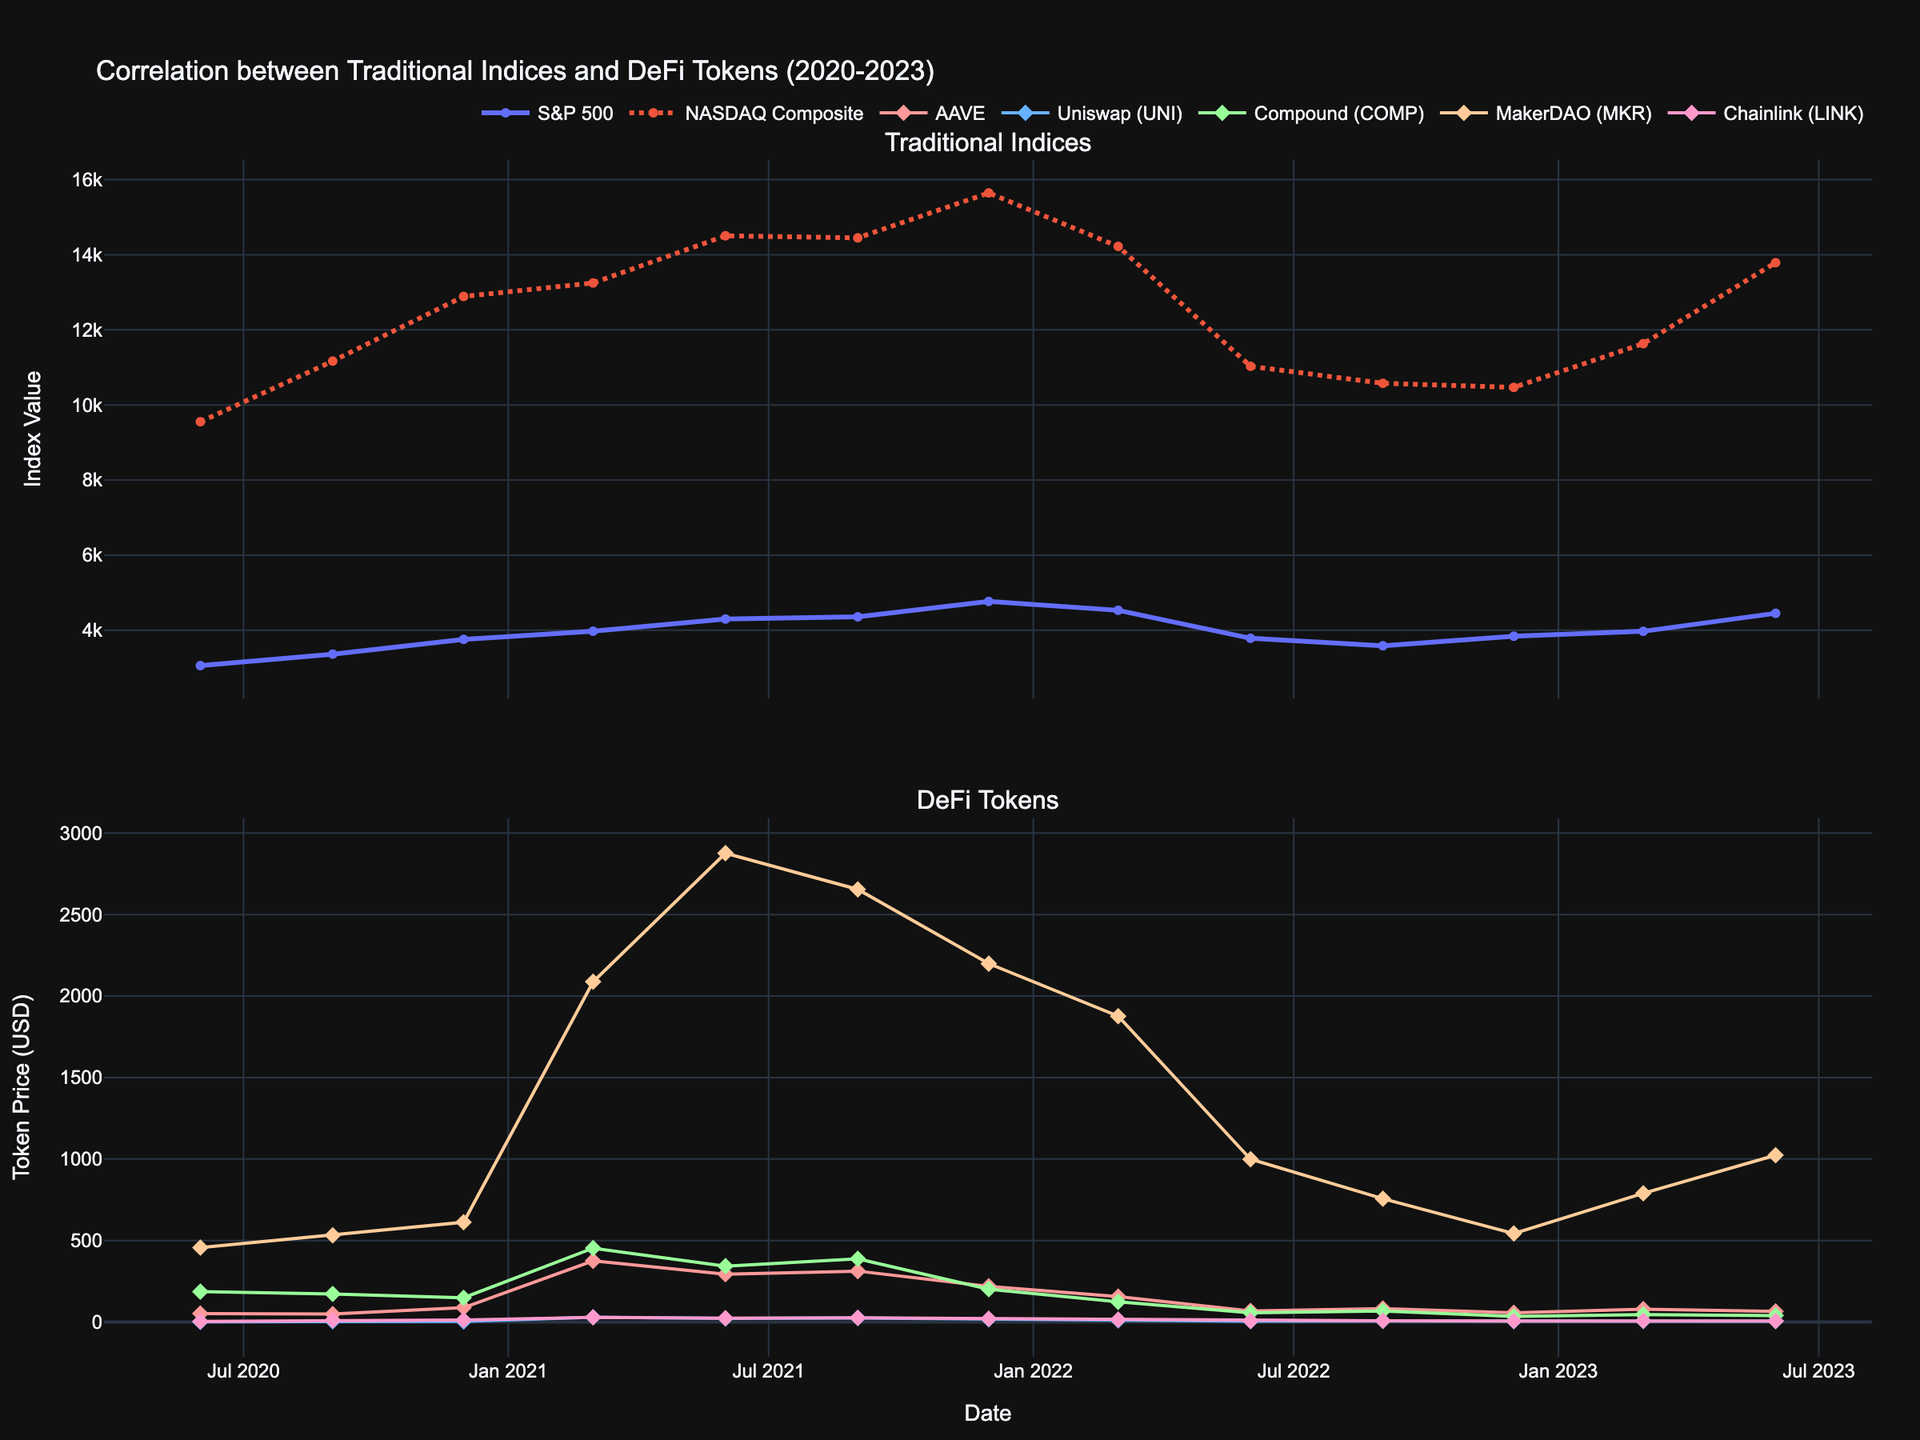Which DeFi token had the highest price in March 2021? Looking at the second subplot, March 2021 shows MakerDAO (MKR) reaching the highest price among the DeFi tokens.
Answer: MakerDAO (MKR) How did the trend of the S&P 500 index compare to the NASDAQ Composite from June 2020 to June 2023? By observing the first subplot, both indices show an overall upward trend. However, the S&P 500 index shows a steadier rise compared to the more volatile NASDAQ Composite.
Answer: S&P 500 is steadier, NASDAQ is more volatile Which DeFi token displayed the most significant price drop between June 2021 and June 2022? Checking the second subplot, AAVE dropped from around 293.78 in June 2021 to 67.89 in June 2022. This is the most significant price drop among the DeFi tokens.
Answer: AAVE What's the difference between the S&P 500 and NASDAQ Composite indices' values in December 2021? For December 2021, the S&P 500 value is 4766.18 and the NASDAQ Composite is 15644.97. The difference is 15644.97 - 4766.18 = 10878.79.
Answer: 10878.79 Which traditional index reached its highest point first, and when did this occur? The first subplot shows the NASDAQ Composite reaching its peak first in December 2021 at a value of 15644.97. The S&P 500 reached its peak in June 2023 but later than NASDAQ.
Answer: NASDAQ Composite, December 2021 What visual attribute differentiates the NASDAQ Composite line from the S&P 500 line in the plot? In the first subplot, the NASDAQ Composite is depicted with a dashed line while the S&P 500 is shown with a solid line.
Answer: NASDAQ Composite is dashed, S&P 500 is solid During which period did Uniswap (UNI) have the highest price, and what was its value? By examining the second subplot, Uniswap (UNI) had its highest price in September 2020, reaching approximately 29.43.
Answer: September 2020, 29.43 Did the prices of Compound (COMP) and Chainlink (LINK) move together or diverge from June 2021 to December 2022? From June 2021 to December 2022, both Compound (COMP) and Chainlink (LINK) show a similar downward trend, indicating they moved together.
Answer: Moved together What is the average price of MakerDAO (MKR) in the first and second quarters of 2022? For Q1 2022: value is 1876.54. For Q2 2022: value is 998.76. Average = (1876.54 + 998.76)/2 = 1437.65.
Answer: 1437.65 